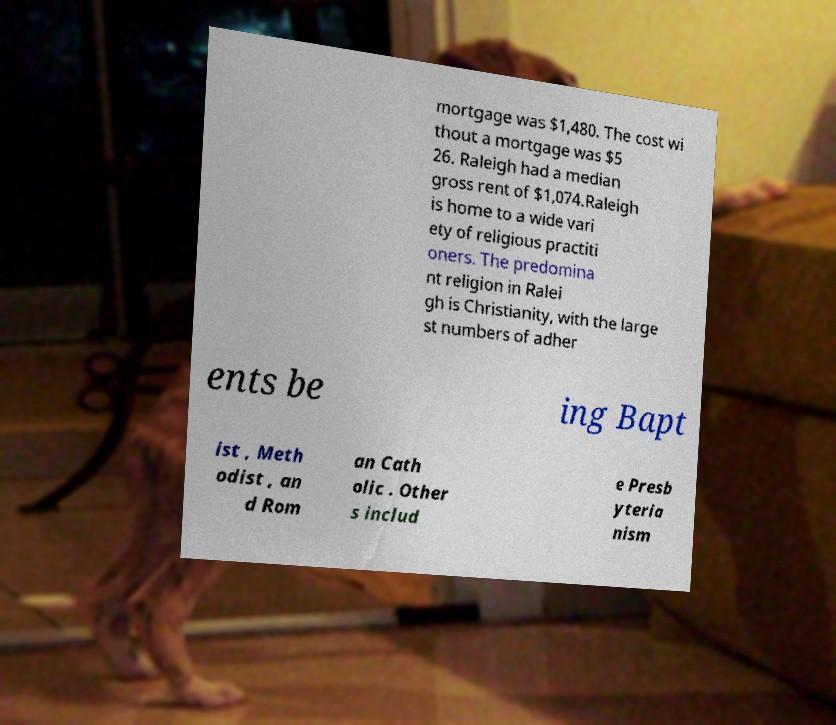What messages or text are displayed in this image? I need them in a readable, typed format. mortgage was $1,480. The cost wi thout a mortgage was $5 26. Raleigh had a median gross rent of $1,074.Raleigh is home to a wide vari ety of religious practiti oners. The predomina nt religion in Ralei gh is Christianity, with the large st numbers of adher ents be ing Bapt ist , Meth odist , an d Rom an Cath olic . Other s includ e Presb yteria nism 